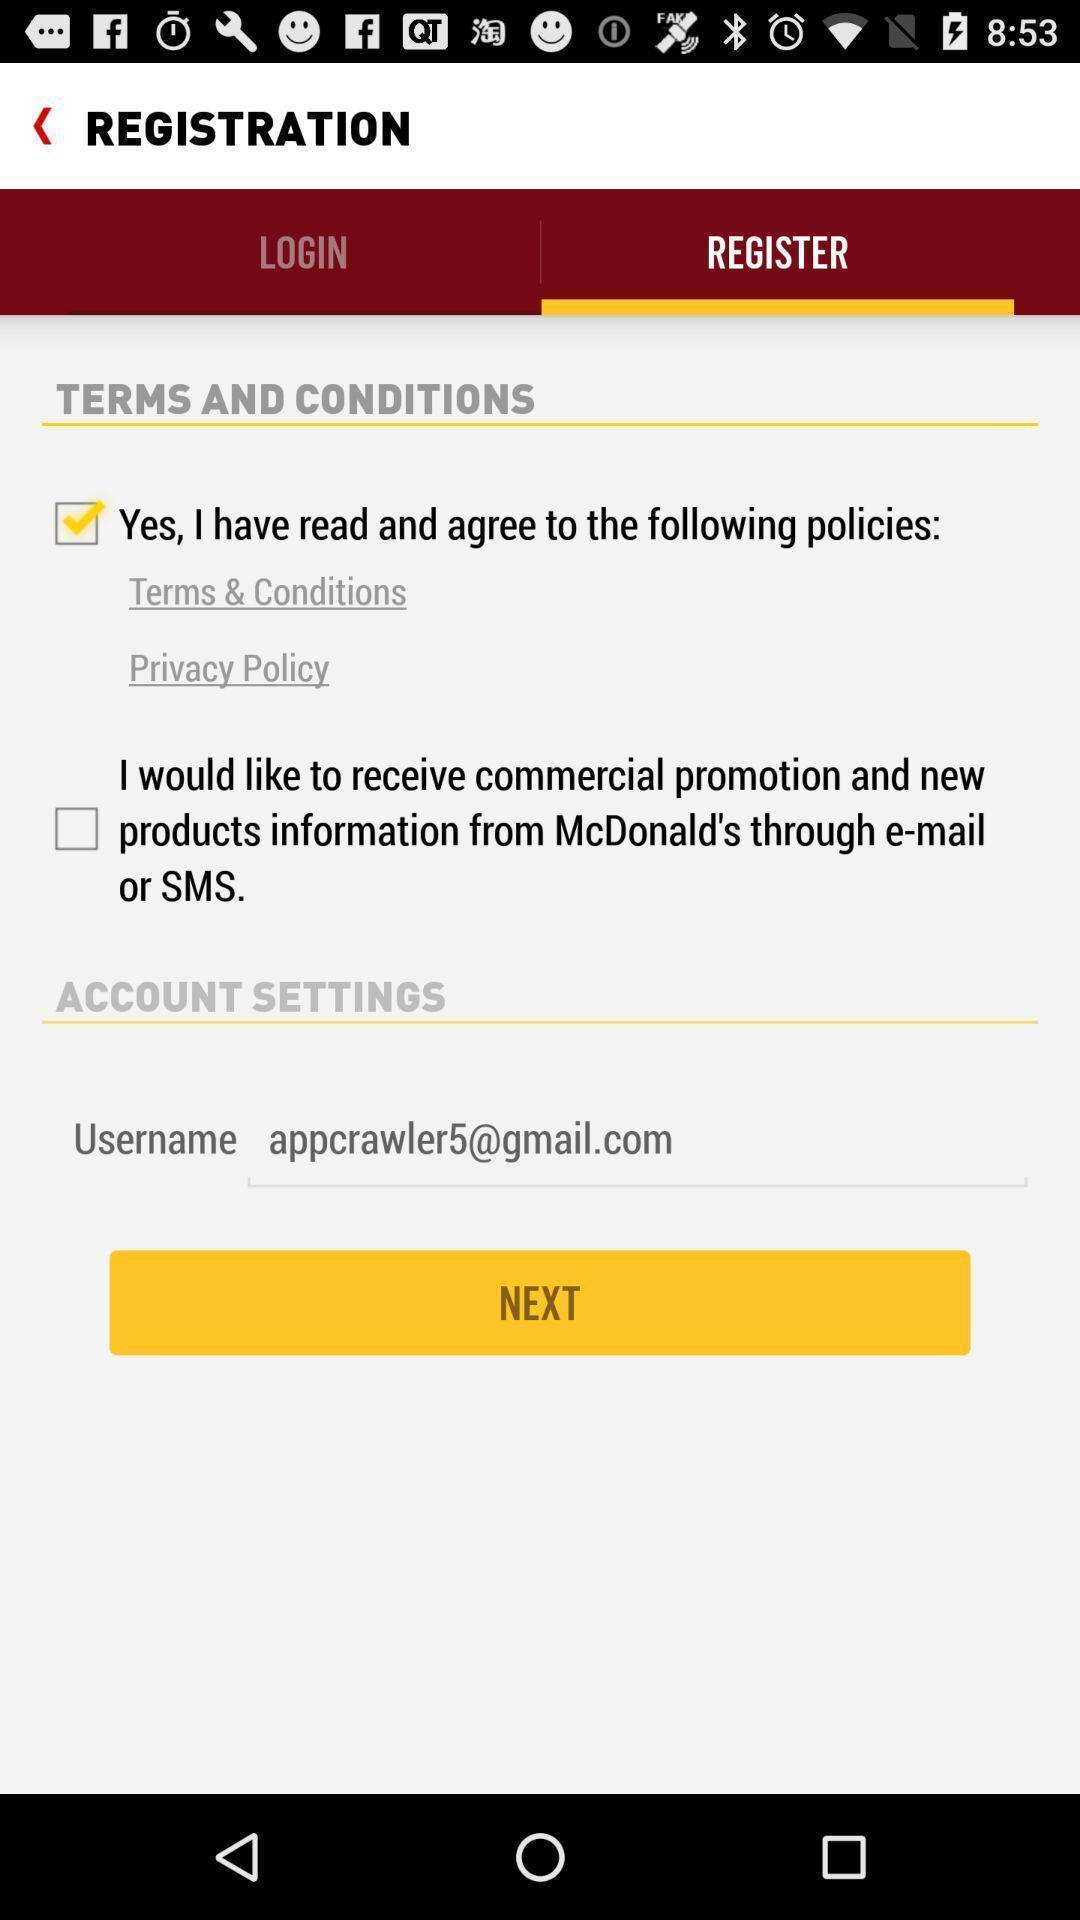Explain what's happening in this screen capture. Screen of registration with terms and conditions. 